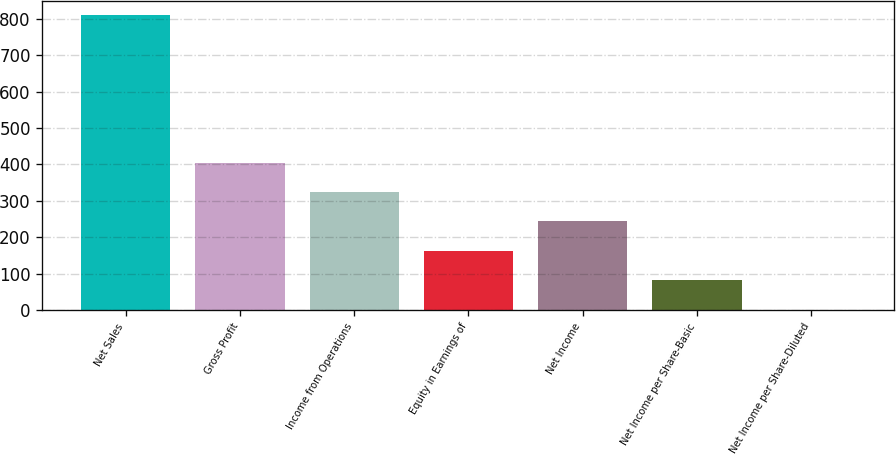Convert chart. <chart><loc_0><loc_0><loc_500><loc_500><bar_chart><fcel>Net Sales<fcel>Gross Profit<fcel>Income from Operations<fcel>Equity in Earnings of<fcel>Net Income<fcel>Net Income per Share-Basic<fcel>Net Income per Share-Diluted<nl><fcel>809.7<fcel>405.12<fcel>324.21<fcel>162.39<fcel>243.3<fcel>81.48<fcel>0.57<nl></chart> 